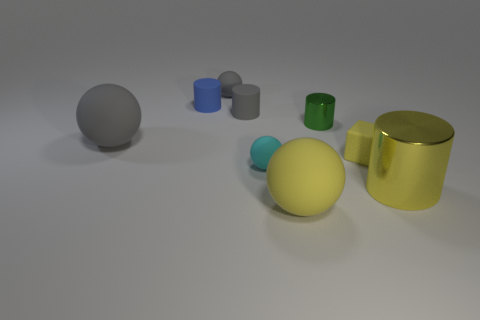What is the shape of the cyan rubber thing that is the same size as the green cylinder?
Offer a very short reply. Sphere. Are there any other things of the same color as the tiny rubber block?
Give a very brief answer. Yes. The yellow ball that is the same material as the small cube is what size?
Provide a short and direct response. Large. Is the shape of the big yellow rubber thing the same as the big rubber thing that is behind the tiny cyan matte sphere?
Provide a succinct answer. Yes. How big is the green metal object?
Provide a short and direct response. Small. There is a small rubber thing that is the same color as the big shiny cylinder; what shape is it?
Ensure brevity in your answer.  Cube. Does the matte ball that is on the right side of the cyan object have the same color as the cylinder in front of the cyan matte object?
Give a very brief answer. Yes. The rubber cube that is the same color as the large cylinder is what size?
Provide a succinct answer. Small. There is a metallic thing that is the same size as the blue rubber object; what is its color?
Provide a short and direct response. Green. Is the number of big metallic things that are in front of the yellow metal thing less than the number of tiny cylinders to the left of the large yellow matte object?
Keep it short and to the point. Yes. 